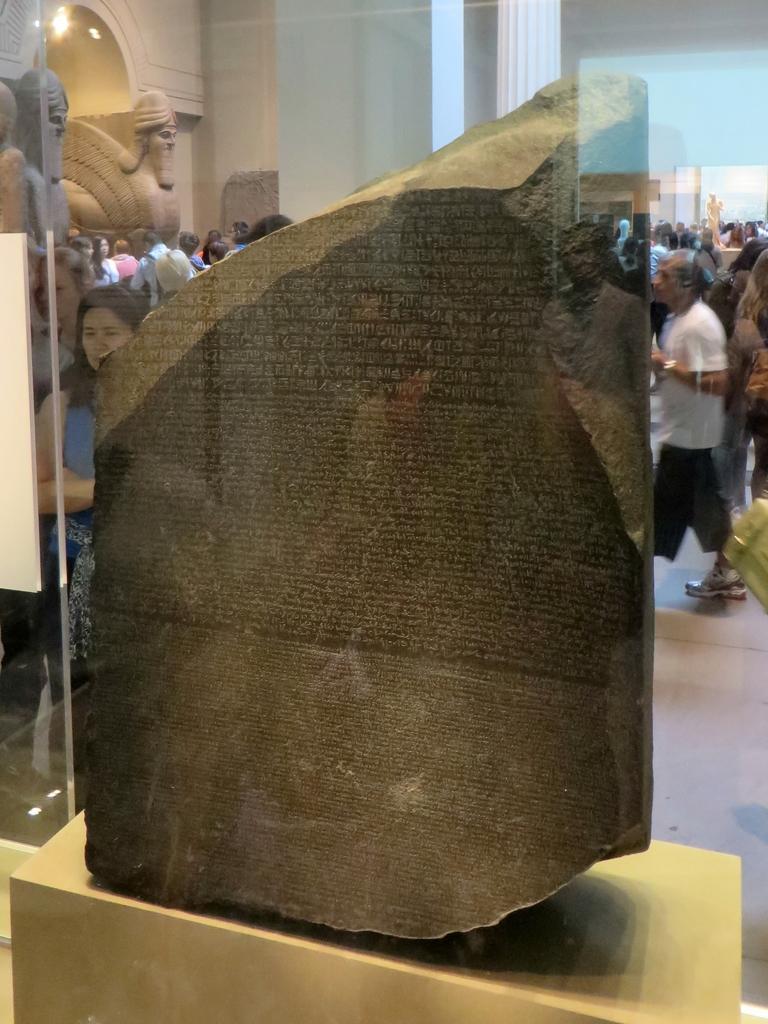Can you describe this image briefly? In this picture we can see a stone, sculptures and a group of people on the floor and in the background we can see a statue. 